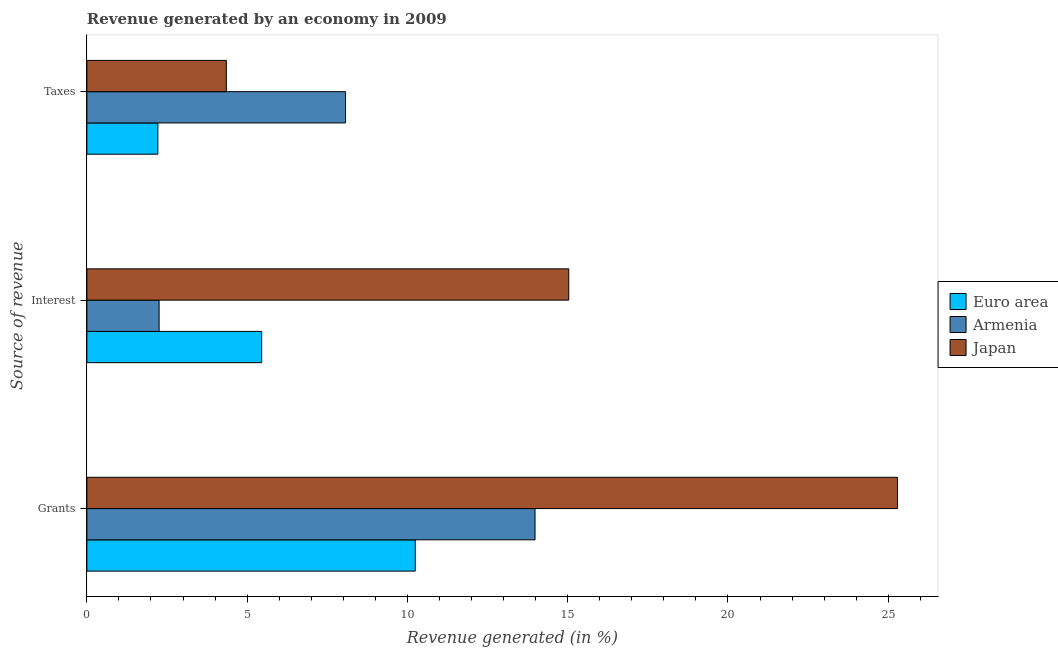How many groups of bars are there?
Offer a terse response. 3. What is the label of the 3rd group of bars from the top?
Your answer should be very brief. Grants. What is the percentage of revenue generated by grants in Armenia?
Your response must be concise. 13.98. Across all countries, what is the maximum percentage of revenue generated by grants?
Your answer should be very brief. 25.29. Across all countries, what is the minimum percentage of revenue generated by taxes?
Offer a very short reply. 2.21. In which country was the percentage of revenue generated by interest minimum?
Your answer should be very brief. Armenia. What is the total percentage of revenue generated by interest in the graph?
Make the answer very short. 22.74. What is the difference between the percentage of revenue generated by interest in Japan and that in Euro area?
Offer a terse response. 9.58. What is the difference between the percentage of revenue generated by taxes in Euro area and the percentage of revenue generated by interest in Japan?
Give a very brief answer. -12.82. What is the average percentage of revenue generated by grants per country?
Your answer should be compact. 16.51. What is the difference between the percentage of revenue generated by grants and percentage of revenue generated by interest in Euro area?
Your answer should be very brief. 4.79. In how many countries, is the percentage of revenue generated by grants greater than 18 %?
Your response must be concise. 1. What is the ratio of the percentage of revenue generated by interest in Japan to that in Armenia?
Give a very brief answer. 6.67. Is the percentage of revenue generated by grants in Armenia less than that in Euro area?
Provide a short and direct response. No. What is the difference between the highest and the second highest percentage of revenue generated by interest?
Offer a terse response. 9.58. What is the difference between the highest and the lowest percentage of revenue generated by interest?
Your response must be concise. 12.78. In how many countries, is the percentage of revenue generated by interest greater than the average percentage of revenue generated by interest taken over all countries?
Your answer should be compact. 1. Is the sum of the percentage of revenue generated by taxes in Japan and Euro area greater than the maximum percentage of revenue generated by grants across all countries?
Make the answer very short. No. How many bars are there?
Ensure brevity in your answer.  9. Are all the bars in the graph horizontal?
Your answer should be very brief. Yes. What is the difference between two consecutive major ticks on the X-axis?
Your answer should be very brief. 5. Does the graph contain grids?
Ensure brevity in your answer.  No. What is the title of the graph?
Keep it short and to the point. Revenue generated by an economy in 2009. Does "Algeria" appear as one of the legend labels in the graph?
Give a very brief answer. No. What is the label or title of the X-axis?
Give a very brief answer. Revenue generated (in %). What is the label or title of the Y-axis?
Ensure brevity in your answer.  Source of revenue. What is the Revenue generated (in %) in Euro area in Grants?
Provide a short and direct response. 10.25. What is the Revenue generated (in %) of Armenia in Grants?
Your answer should be compact. 13.98. What is the Revenue generated (in %) of Japan in Grants?
Your response must be concise. 25.29. What is the Revenue generated (in %) in Euro area in Interest?
Offer a terse response. 5.45. What is the Revenue generated (in %) of Armenia in Interest?
Your answer should be compact. 2.25. What is the Revenue generated (in %) of Japan in Interest?
Your response must be concise. 15.03. What is the Revenue generated (in %) of Euro area in Taxes?
Your answer should be very brief. 2.21. What is the Revenue generated (in %) in Armenia in Taxes?
Offer a terse response. 8.07. What is the Revenue generated (in %) in Japan in Taxes?
Ensure brevity in your answer.  4.35. Across all Source of revenue, what is the maximum Revenue generated (in %) in Euro area?
Offer a terse response. 10.25. Across all Source of revenue, what is the maximum Revenue generated (in %) in Armenia?
Make the answer very short. 13.98. Across all Source of revenue, what is the maximum Revenue generated (in %) in Japan?
Provide a succinct answer. 25.29. Across all Source of revenue, what is the minimum Revenue generated (in %) of Euro area?
Offer a terse response. 2.21. Across all Source of revenue, what is the minimum Revenue generated (in %) of Armenia?
Provide a short and direct response. 2.25. Across all Source of revenue, what is the minimum Revenue generated (in %) in Japan?
Make the answer very short. 4.35. What is the total Revenue generated (in %) in Euro area in the graph?
Provide a short and direct response. 17.91. What is the total Revenue generated (in %) of Armenia in the graph?
Keep it short and to the point. 24.3. What is the total Revenue generated (in %) in Japan in the graph?
Keep it short and to the point. 44.67. What is the difference between the Revenue generated (in %) in Euro area in Grants and that in Interest?
Give a very brief answer. 4.79. What is the difference between the Revenue generated (in %) of Armenia in Grants and that in Interest?
Ensure brevity in your answer.  11.73. What is the difference between the Revenue generated (in %) in Japan in Grants and that in Interest?
Keep it short and to the point. 10.26. What is the difference between the Revenue generated (in %) in Euro area in Grants and that in Taxes?
Ensure brevity in your answer.  8.03. What is the difference between the Revenue generated (in %) of Armenia in Grants and that in Taxes?
Your answer should be compact. 5.91. What is the difference between the Revenue generated (in %) of Japan in Grants and that in Taxes?
Your response must be concise. 20.94. What is the difference between the Revenue generated (in %) in Euro area in Interest and that in Taxes?
Offer a terse response. 3.24. What is the difference between the Revenue generated (in %) in Armenia in Interest and that in Taxes?
Ensure brevity in your answer.  -5.82. What is the difference between the Revenue generated (in %) in Japan in Interest and that in Taxes?
Keep it short and to the point. 10.68. What is the difference between the Revenue generated (in %) of Euro area in Grants and the Revenue generated (in %) of Armenia in Interest?
Give a very brief answer. 7.99. What is the difference between the Revenue generated (in %) in Euro area in Grants and the Revenue generated (in %) in Japan in Interest?
Your answer should be very brief. -4.79. What is the difference between the Revenue generated (in %) of Armenia in Grants and the Revenue generated (in %) of Japan in Interest?
Keep it short and to the point. -1.05. What is the difference between the Revenue generated (in %) of Euro area in Grants and the Revenue generated (in %) of Armenia in Taxes?
Make the answer very short. 2.18. What is the difference between the Revenue generated (in %) in Euro area in Grants and the Revenue generated (in %) in Japan in Taxes?
Make the answer very short. 5.89. What is the difference between the Revenue generated (in %) in Armenia in Grants and the Revenue generated (in %) in Japan in Taxes?
Your answer should be very brief. 9.63. What is the difference between the Revenue generated (in %) in Euro area in Interest and the Revenue generated (in %) in Armenia in Taxes?
Ensure brevity in your answer.  -2.62. What is the difference between the Revenue generated (in %) of Euro area in Interest and the Revenue generated (in %) of Japan in Taxes?
Your response must be concise. 1.1. What is the difference between the Revenue generated (in %) in Armenia in Interest and the Revenue generated (in %) in Japan in Taxes?
Provide a short and direct response. -2.1. What is the average Revenue generated (in %) of Euro area per Source of revenue?
Make the answer very short. 5.97. What is the average Revenue generated (in %) in Armenia per Source of revenue?
Your answer should be compact. 8.1. What is the average Revenue generated (in %) of Japan per Source of revenue?
Offer a terse response. 14.89. What is the difference between the Revenue generated (in %) of Euro area and Revenue generated (in %) of Armenia in Grants?
Make the answer very short. -3.74. What is the difference between the Revenue generated (in %) in Euro area and Revenue generated (in %) in Japan in Grants?
Keep it short and to the point. -15.04. What is the difference between the Revenue generated (in %) of Armenia and Revenue generated (in %) of Japan in Grants?
Keep it short and to the point. -11.31. What is the difference between the Revenue generated (in %) in Euro area and Revenue generated (in %) in Japan in Interest?
Offer a very short reply. -9.58. What is the difference between the Revenue generated (in %) in Armenia and Revenue generated (in %) in Japan in Interest?
Offer a very short reply. -12.78. What is the difference between the Revenue generated (in %) of Euro area and Revenue generated (in %) of Armenia in Taxes?
Keep it short and to the point. -5.86. What is the difference between the Revenue generated (in %) of Euro area and Revenue generated (in %) of Japan in Taxes?
Give a very brief answer. -2.14. What is the difference between the Revenue generated (in %) of Armenia and Revenue generated (in %) of Japan in Taxes?
Your response must be concise. 3.72. What is the ratio of the Revenue generated (in %) in Euro area in Grants to that in Interest?
Make the answer very short. 1.88. What is the ratio of the Revenue generated (in %) in Armenia in Grants to that in Interest?
Your answer should be very brief. 6.2. What is the ratio of the Revenue generated (in %) in Japan in Grants to that in Interest?
Offer a very short reply. 1.68. What is the ratio of the Revenue generated (in %) in Euro area in Grants to that in Taxes?
Make the answer very short. 4.63. What is the ratio of the Revenue generated (in %) in Armenia in Grants to that in Taxes?
Your answer should be compact. 1.73. What is the ratio of the Revenue generated (in %) in Japan in Grants to that in Taxes?
Keep it short and to the point. 5.81. What is the ratio of the Revenue generated (in %) of Euro area in Interest to that in Taxes?
Make the answer very short. 2.46. What is the ratio of the Revenue generated (in %) of Armenia in Interest to that in Taxes?
Offer a terse response. 0.28. What is the ratio of the Revenue generated (in %) of Japan in Interest to that in Taxes?
Your response must be concise. 3.46. What is the difference between the highest and the second highest Revenue generated (in %) in Euro area?
Offer a very short reply. 4.79. What is the difference between the highest and the second highest Revenue generated (in %) of Armenia?
Your answer should be very brief. 5.91. What is the difference between the highest and the second highest Revenue generated (in %) in Japan?
Ensure brevity in your answer.  10.26. What is the difference between the highest and the lowest Revenue generated (in %) of Euro area?
Provide a succinct answer. 8.03. What is the difference between the highest and the lowest Revenue generated (in %) of Armenia?
Your answer should be very brief. 11.73. What is the difference between the highest and the lowest Revenue generated (in %) of Japan?
Provide a succinct answer. 20.94. 